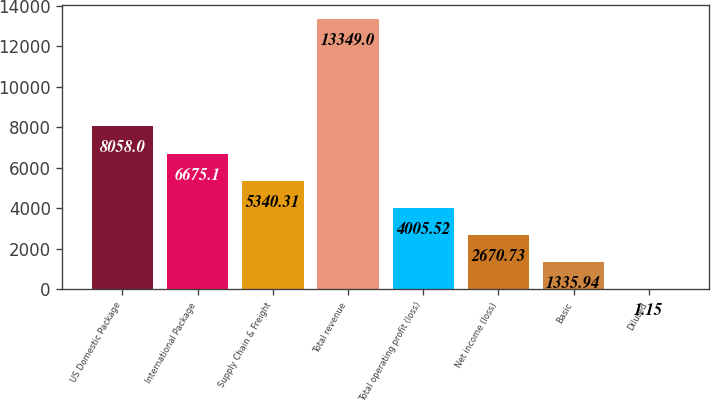<chart> <loc_0><loc_0><loc_500><loc_500><bar_chart><fcel>US Domestic Package<fcel>International Package<fcel>Supply Chain & Freight<fcel>Total revenue<fcel>Total operating profit (loss)<fcel>Net income (loss)<fcel>Basic<fcel>Diluted<nl><fcel>8058<fcel>6675.1<fcel>5340.31<fcel>13349<fcel>4005.52<fcel>2670.73<fcel>1335.94<fcel>1.15<nl></chart> 